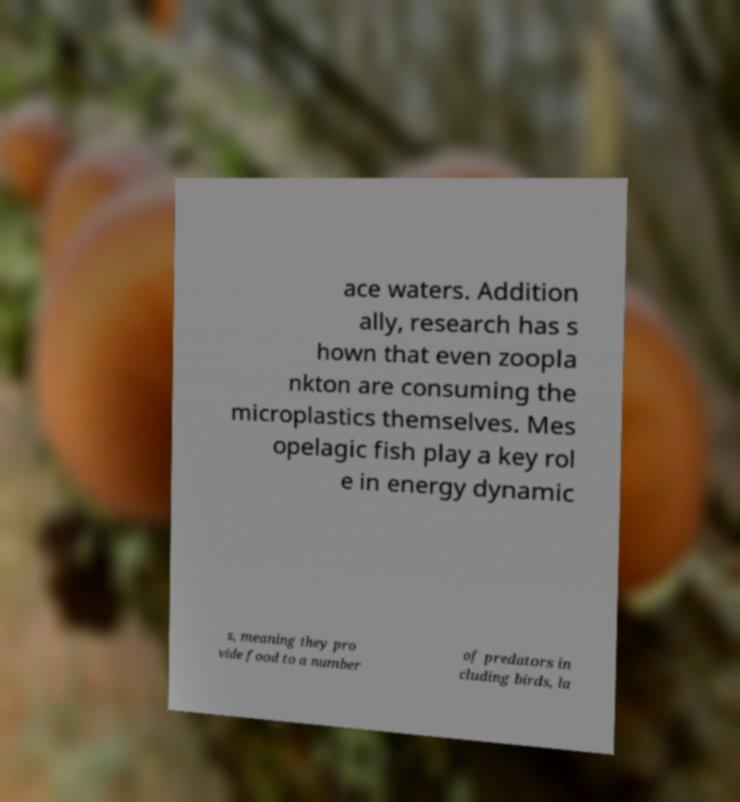There's text embedded in this image that I need extracted. Can you transcribe it verbatim? ace waters. Addition ally, research has s hown that even zoopla nkton are consuming the microplastics themselves. Mes opelagic fish play a key rol e in energy dynamic s, meaning they pro vide food to a number of predators in cluding birds, la 